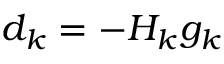<formula> <loc_0><loc_0><loc_500><loc_500>d _ { k } = - H _ { k } g _ { k }</formula> 